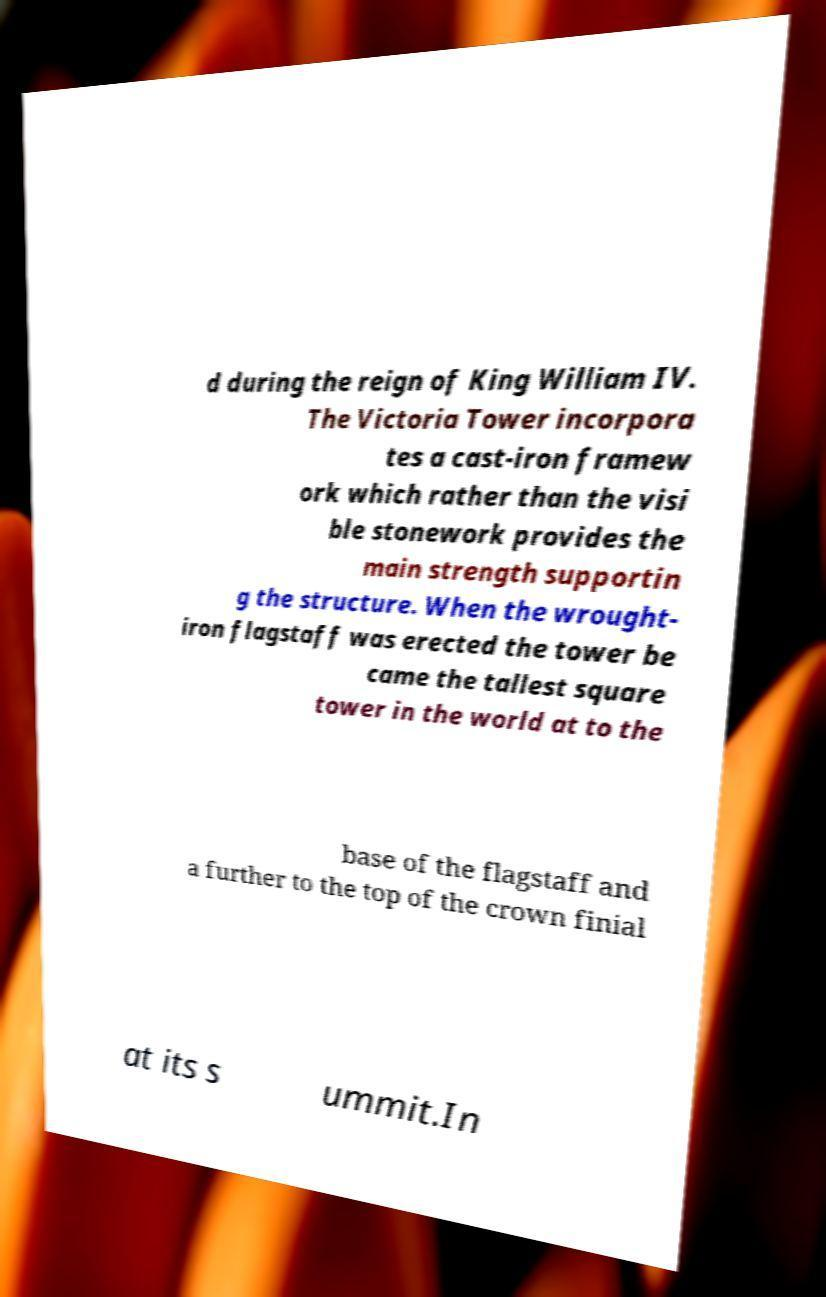Please identify and transcribe the text found in this image. d during the reign of King William IV. The Victoria Tower incorpora tes a cast-iron framew ork which rather than the visi ble stonework provides the main strength supportin g the structure. When the wrought- iron flagstaff was erected the tower be came the tallest square tower in the world at to the base of the flagstaff and a further to the top of the crown finial at its s ummit.In 